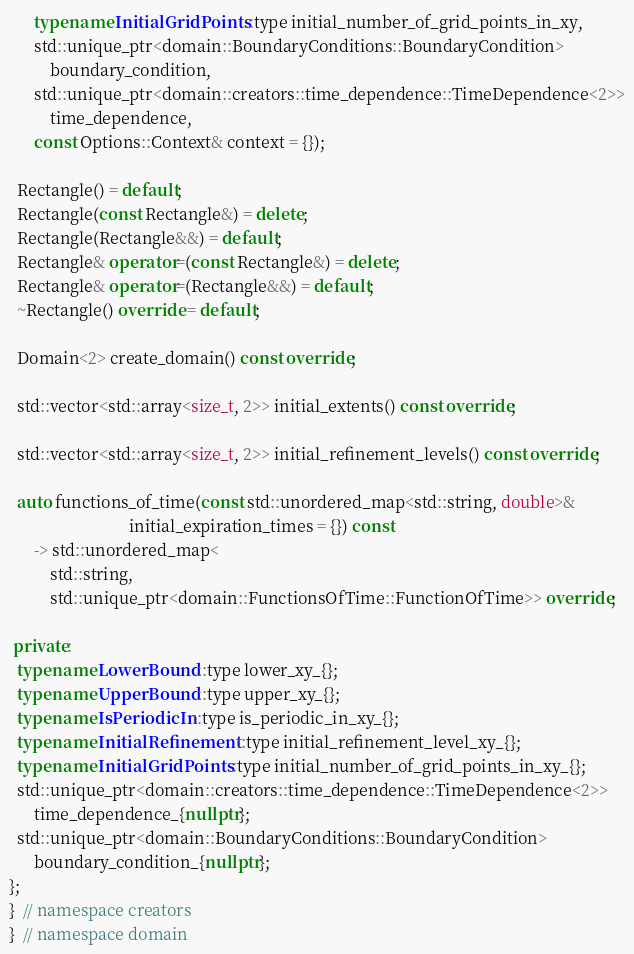<code> <loc_0><loc_0><loc_500><loc_500><_C++_>      typename InitialGridPoints::type initial_number_of_grid_points_in_xy,
      std::unique_ptr<domain::BoundaryConditions::BoundaryCondition>
          boundary_condition,
      std::unique_ptr<domain::creators::time_dependence::TimeDependence<2>>
          time_dependence,
      const Options::Context& context = {});

  Rectangle() = default;
  Rectangle(const Rectangle&) = delete;
  Rectangle(Rectangle&&) = default;
  Rectangle& operator=(const Rectangle&) = delete;
  Rectangle& operator=(Rectangle&&) = default;
  ~Rectangle() override = default;

  Domain<2> create_domain() const override;

  std::vector<std::array<size_t, 2>> initial_extents() const override;

  std::vector<std::array<size_t, 2>> initial_refinement_levels() const override;

  auto functions_of_time(const std::unordered_map<std::string, double>&
                             initial_expiration_times = {}) const
      -> std::unordered_map<
          std::string,
          std::unique_ptr<domain::FunctionsOfTime::FunctionOfTime>> override;

 private:
  typename LowerBound::type lower_xy_{};
  typename UpperBound::type upper_xy_{};
  typename IsPeriodicIn::type is_periodic_in_xy_{};
  typename InitialRefinement::type initial_refinement_level_xy_{};
  typename InitialGridPoints::type initial_number_of_grid_points_in_xy_{};
  std::unique_ptr<domain::creators::time_dependence::TimeDependence<2>>
      time_dependence_{nullptr};
  std::unique_ptr<domain::BoundaryConditions::BoundaryCondition>
      boundary_condition_{nullptr};
};
}  // namespace creators
}  // namespace domain
</code> 